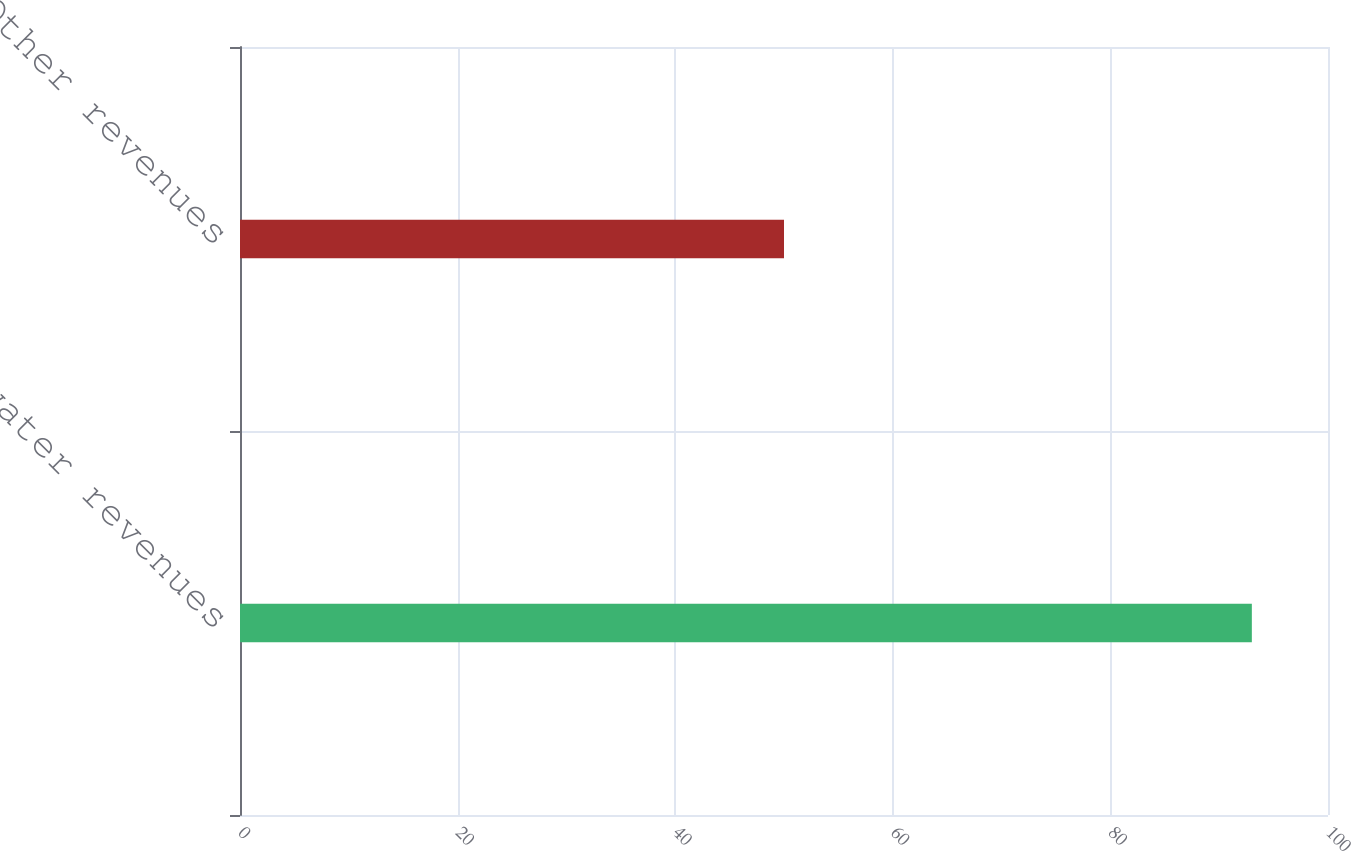Convert chart to OTSL. <chart><loc_0><loc_0><loc_500><loc_500><bar_chart><fcel>Wastewater revenues<fcel>Other revenues<nl><fcel>93<fcel>50<nl></chart> 